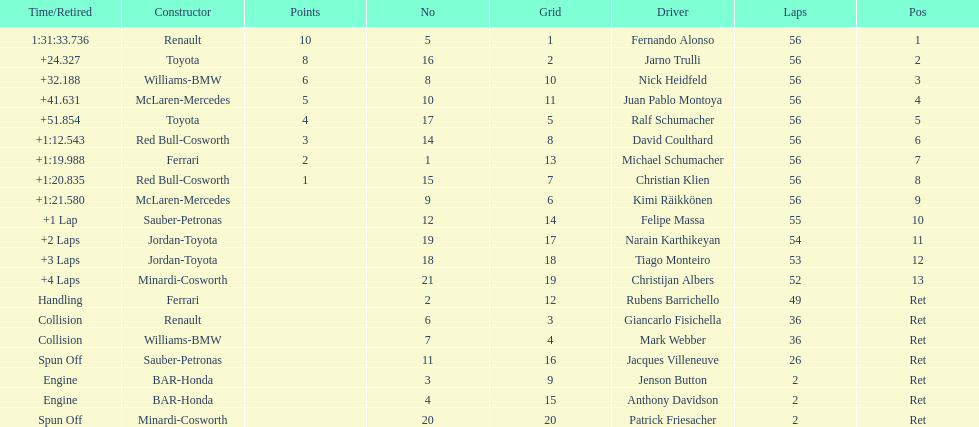Could you parse the entire table as a dict? {'header': ['Time/Retired', 'Constructor', 'Points', 'No', 'Grid', 'Driver', 'Laps', 'Pos'], 'rows': [['1:31:33.736', 'Renault', '10', '5', '1', 'Fernando Alonso', '56', '1'], ['+24.327', 'Toyota', '8', '16', '2', 'Jarno Trulli', '56', '2'], ['+32.188', 'Williams-BMW', '6', '8', '10', 'Nick Heidfeld', '56', '3'], ['+41.631', 'McLaren-Mercedes', '5', '10', '11', 'Juan Pablo Montoya', '56', '4'], ['+51.854', 'Toyota', '4', '17', '5', 'Ralf Schumacher', '56', '5'], ['+1:12.543', 'Red Bull-Cosworth', '3', '14', '8', 'David Coulthard', '56', '6'], ['+1:19.988', 'Ferrari', '2', '1', '13', 'Michael Schumacher', '56', '7'], ['+1:20.835', 'Red Bull-Cosworth', '1', '15', '7', 'Christian Klien', '56', '8'], ['+1:21.580', 'McLaren-Mercedes', '', '9', '6', 'Kimi Räikkönen', '56', '9'], ['+1 Lap', 'Sauber-Petronas', '', '12', '14', 'Felipe Massa', '55', '10'], ['+2 Laps', 'Jordan-Toyota', '', '19', '17', 'Narain Karthikeyan', '54', '11'], ['+3 Laps', 'Jordan-Toyota', '', '18', '18', 'Tiago Monteiro', '53', '12'], ['+4 Laps', 'Minardi-Cosworth', '', '21', '19', 'Christijan Albers', '52', '13'], ['Handling', 'Ferrari', '', '2', '12', 'Rubens Barrichello', '49', 'Ret'], ['Collision', 'Renault', '', '6', '3', 'Giancarlo Fisichella', '36', 'Ret'], ['Collision', 'Williams-BMW', '', '7', '4', 'Mark Webber', '36', 'Ret'], ['Spun Off', 'Sauber-Petronas', '', '11', '16', 'Jacques Villeneuve', '26', 'Ret'], ['Engine', 'BAR-Honda', '', '3', '9', 'Jenson Button', '2', 'Ret'], ['Engine', 'BAR-Honda', '', '4', '15', 'Anthony Davidson', '2', 'Ret'], ['Spun Off', 'Minardi-Cosworth', '', '20', '20', 'Patrick Friesacher', '2', 'Ret']]} Who was the driver that finished first? Fernando Alonso. 